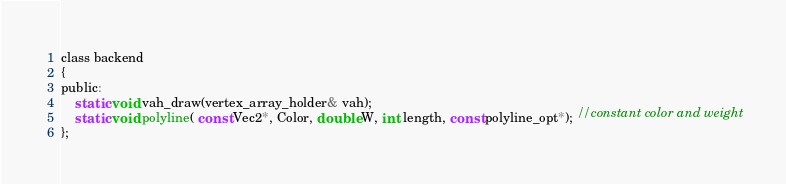<code> <loc_0><loc_0><loc_500><loc_500><_C_>class backend
{
public:
	static void vah_draw(vertex_array_holder& vah);
	static void polyline( const Vec2*, Color, double W, int length, const polyline_opt*); //constant color and weight
};
</code> 